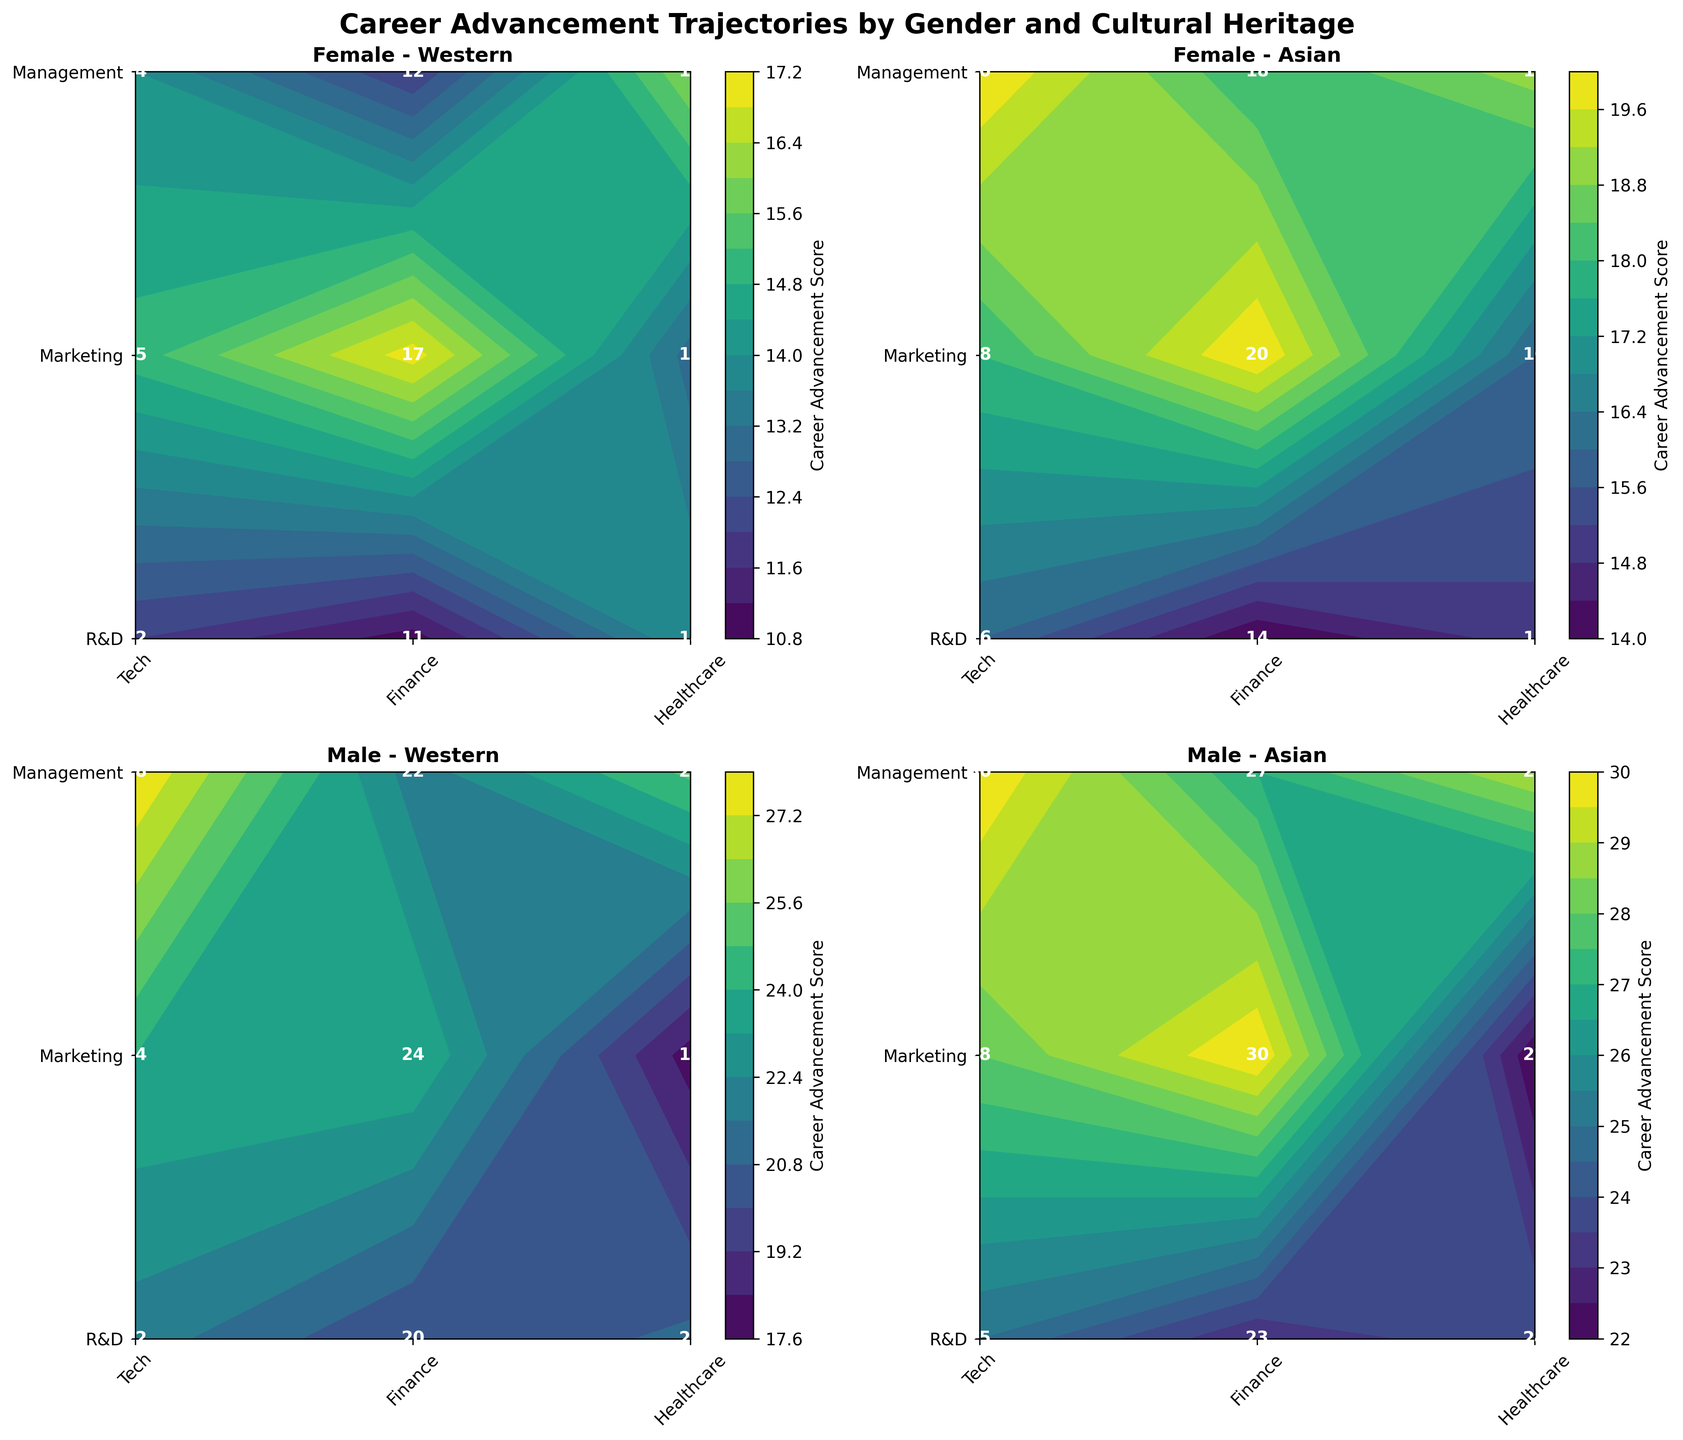Which career category has the highest advancement score for Female Asian professionals in Tech? To find this, locate the subplot "Female - Asian", identify the "Tech" industry along the x-axis, and compare the "R&D," "Marketing," and "Management" scores. The highest score in this cell is 20 for "Management".
Answer: Management What is the title of the entire figure? The title appears at the top of the figure and summarizes the content. It reads "Career Advancement Trajectories by Gender and Cultural Heritage".
Answer: Career Advancement Trajectories by Gender and Cultural Heritage Which gender and cultural heritage group has the highest career advancement score in Marketing? Compare the highest Marketing scores across all subplots. "Male - Asian" shows the highest score of 30 in Marketing.
Answer: Male - Asian What is the lowest scoring industry for Female Western professionals in R&D? In the subplot "Female - Western," check the R&D values across all industries. "Finance" has the lowest score, which is 11.
Answer: Finance Compare the career advancement scores in Management between Male Western and Male Asian professionals in Tech. Focus on the "Tech" values in Management for both "Male - Western" and "Male - Asian". Male Western has 28, while Male Asian has 30.
Answer: Male Asian has higher scores Which career category has the smallest range of scores for Female professionals across all industries? Observe the "Female" subplots, find the range for each career category by subtracting the lowest score from the highest score. "R&D" ranges from 11 to 16 (range=5), "Marketing" from 13 to 20 (range=7), "Management" from 12 to 19 (range=7). The smallest range is in "R&D".
Answer: R&D Which industry has the most similar career advancement scores across different cultural heritages for Males in Marketing? Compare the Marketing scores for "Male - Western" and "Male - Asian" in each industry. "Tech" has scores of 24 (Western) and 28 (Asian), "Finance" 24 (Western) and 30 (Asian), "Healthcare" 18 (Western) and 22 (Asian). The most similar scores are in "Healthcare" (18 and 22).
Answer: Healthcare What is the average career advancement score in Management for Asian professionals in Finance? Look at the "Finance" Management scores for both genders in Asian subplots. Female: 18, Male: 27. The average is (18+27)/2 = 22.5
Answer: 22.5 Which subplot shows the greatest diversity in advancement scores across different career categories? Examine the difference between the highest and lowest scores within each subplot. "Male - Asian" has scores ranging from 22 to 30.
Answer: Male - Asian 